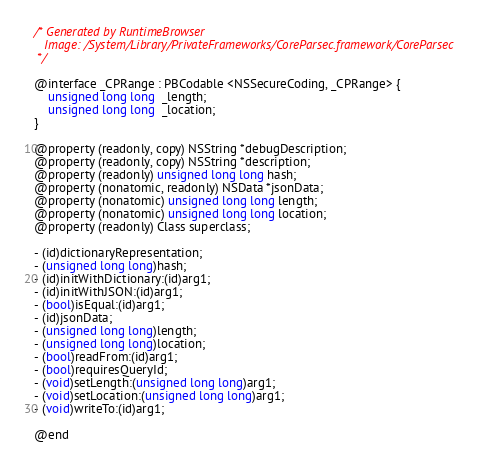Convert code to text. <code><loc_0><loc_0><loc_500><loc_500><_C_>/* Generated by RuntimeBrowser
   Image: /System/Library/PrivateFrameworks/CoreParsec.framework/CoreParsec
 */

@interface _CPRange : PBCodable <NSSecureCoding, _CPRange> {
    unsigned long long  _length;
    unsigned long long  _location;
}

@property (readonly, copy) NSString *debugDescription;
@property (readonly, copy) NSString *description;
@property (readonly) unsigned long long hash;
@property (nonatomic, readonly) NSData *jsonData;
@property (nonatomic) unsigned long long length;
@property (nonatomic) unsigned long long location;
@property (readonly) Class superclass;

- (id)dictionaryRepresentation;
- (unsigned long long)hash;
- (id)initWithDictionary:(id)arg1;
- (id)initWithJSON:(id)arg1;
- (bool)isEqual:(id)arg1;
- (id)jsonData;
- (unsigned long long)length;
- (unsigned long long)location;
- (bool)readFrom:(id)arg1;
- (bool)requiresQueryId;
- (void)setLength:(unsigned long long)arg1;
- (void)setLocation:(unsigned long long)arg1;
- (void)writeTo:(id)arg1;

@end
</code> 